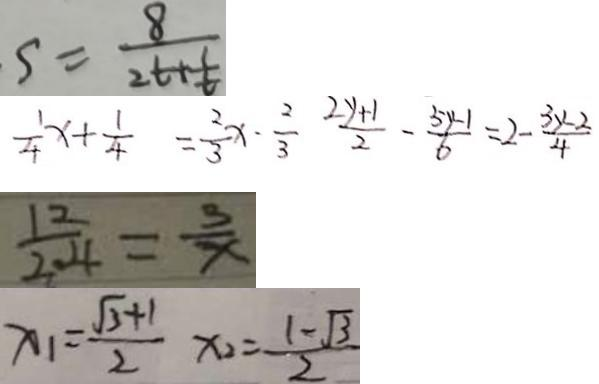<formula> <loc_0><loc_0><loc_500><loc_500>s = \frac { 8 } { 2 t + \frac { 1 } { t } } 
 \frac { 1 } { 4 } x + \frac { 1 } { 4 } = \frac { 2 } { 3 } x - \frac { 2 } { 3 } \frac { 2 y + 1 } { 2 } - \frac { 5 y - 1 } { 6 } = 2 - \frac { 3 y - 2 } { 4 } 
 \frac { 1 2 } { 2 . 4 } = \frac { 3 } { x } 
 x _ { 1 } = \frac { \sqrt { 3 } + 1 } { 2 } x _ { 2 } = \frac { 1 - \sqrt { 3 } } { 2 }</formula> 